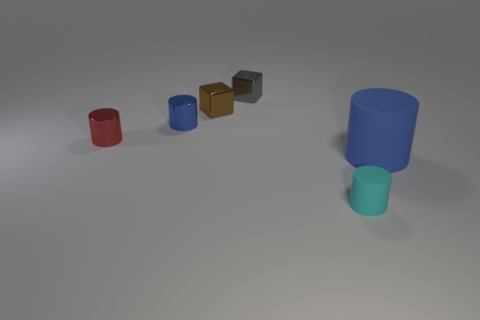Subtract all small blue shiny cylinders. How many cylinders are left? 3 How many blue cylinders must be subtracted to get 1 blue cylinders? 1 Subtract all yellow balls. How many gray cubes are left? 1 Add 1 shiny balls. How many shiny balls exist? 1 Add 2 gray shiny objects. How many objects exist? 8 Subtract all cyan cylinders. How many cylinders are left? 3 Subtract 1 blue cylinders. How many objects are left? 5 Subtract all blocks. How many objects are left? 4 Subtract 1 cylinders. How many cylinders are left? 3 Subtract all gray cylinders. Subtract all purple blocks. How many cylinders are left? 4 